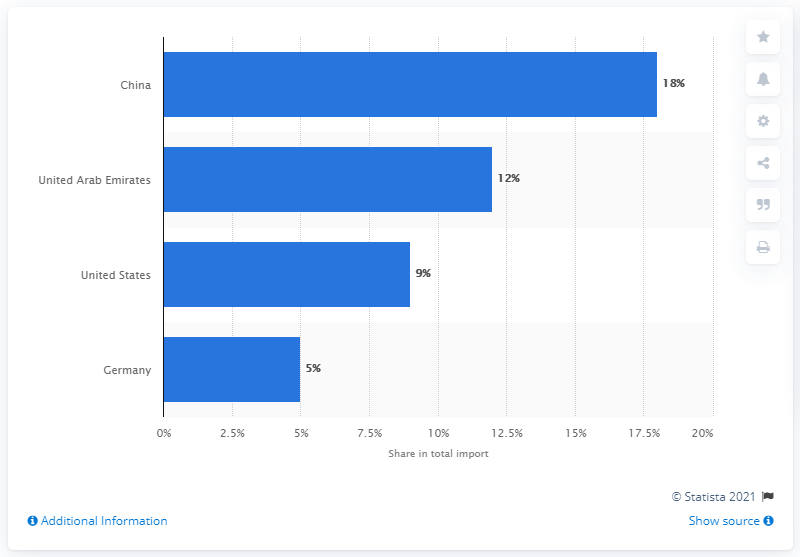Identify some key points in this picture. In 2019, China was Saudi Arabia's most important import partner, indicating a significant trade relationship between the two countries. 